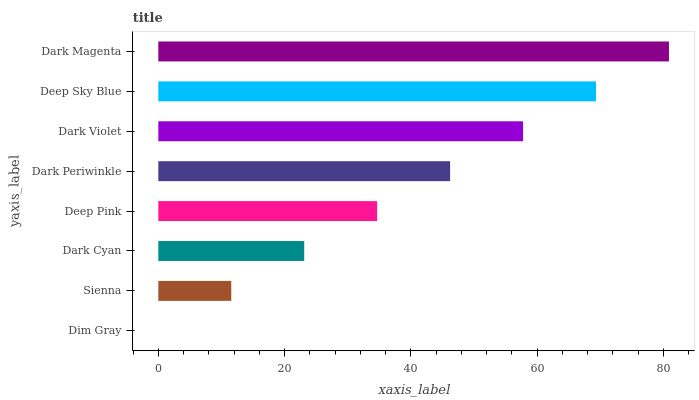Is Dim Gray the minimum?
Answer yes or no. Yes. Is Dark Magenta the maximum?
Answer yes or no. Yes. Is Sienna the minimum?
Answer yes or no. No. Is Sienna the maximum?
Answer yes or no. No. Is Sienna greater than Dim Gray?
Answer yes or no. Yes. Is Dim Gray less than Sienna?
Answer yes or no. Yes. Is Dim Gray greater than Sienna?
Answer yes or no. No. Is Sienna less than Dim Gray?
Answer yes or no. No. Is Dark Periwinkle the high median?
Answer yes or no. Yes. Is Deep Pink the low median?
Answer yes or no. Yes. Is Dark Cyan the high median?
Answer yes or no. No. Is Deep Sky Blue the low median?
Answer yes or no. No. 